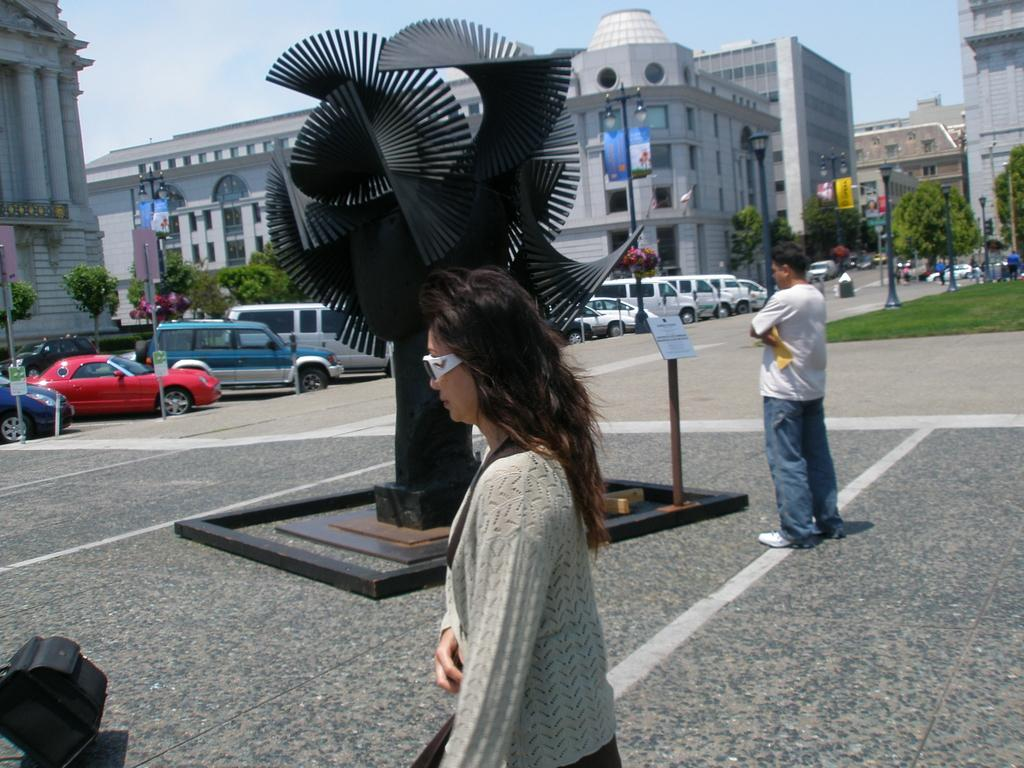What can be seen in front of the building in the image? There are cars parked in front of the building. What is located in the middle of the road in the image? There is a sculpture in the middle of the road. Are there any people present in the image? Yes, there are people standing around in the image. What type of needle is being used by the school in the image? There is no school or needle present in the image. How does the sleet affect the cars parked in front of the building? There is no mention of sleet in the image, so its effect on the cars cannot be determined. 